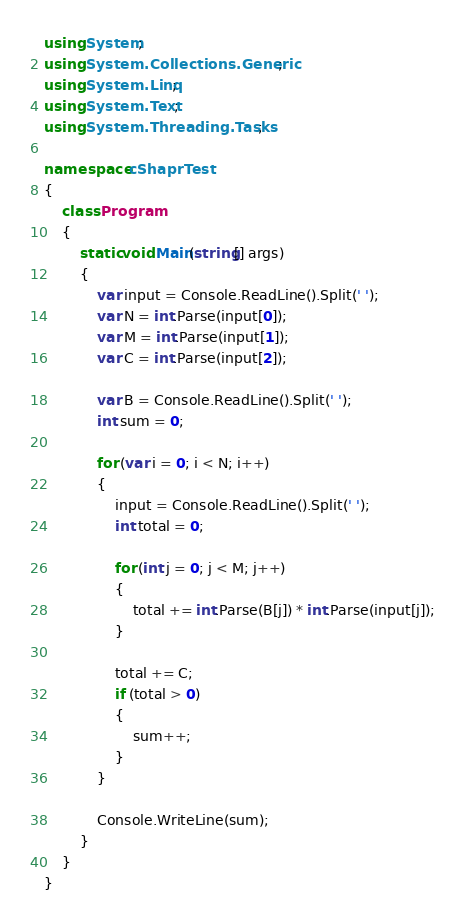Convert code to text. <code><loc_0><loc_0><loc_500><loc_500><_C#_>using System;
using System.Collections.Generic;
using System.Linq;
using System.Text;
using System.Threading.Tasks;

namespace cShaprTest
{
    class Program
    {
        static void Main(string[] args)
        {
            var input = Console.ReadLine().Split(' ');
            var N = int.Parse(input[0]);
            var M = int.Parse(input[1]);
            var C = int.Parse(input[2]);

            var B = Console.ReadLine().Split(' ');
            int sum = 0;

            for (var i = 0; i < N; i++)
            {
                input = Console.ReadLine().Split(' ');
                int total = 0;

                for (int j = 0; j < M; j++)
                {
                    total += int.Parse(B[j]) * int.Parse(input[j]);
                }

                total += C;
                if (total > 0)
                {
                    sum++;
                }
            }

            Console.WriteLine(sum);
        }
    }
}
</code> 